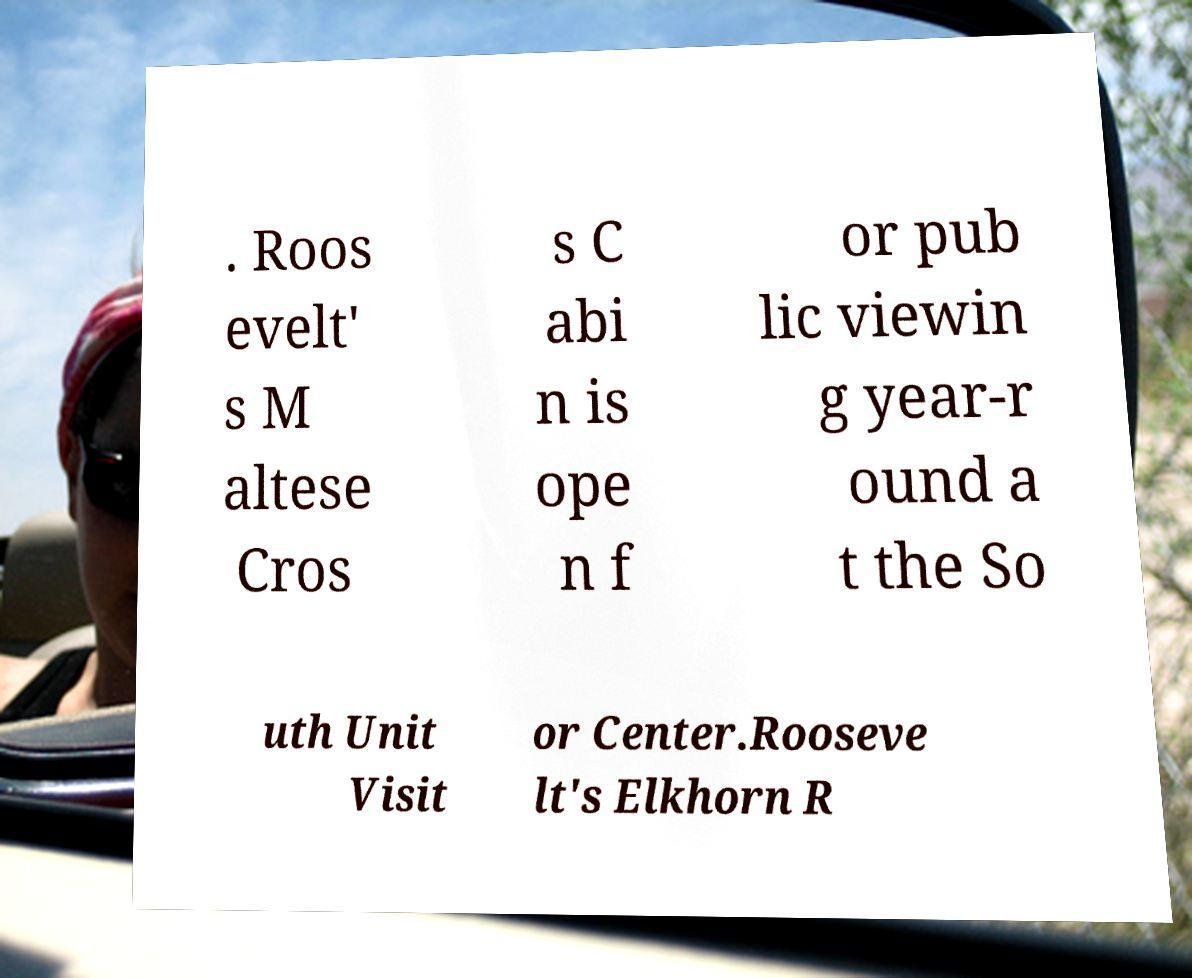Could you assist in decoding the text presented in this image and type it out clearly? . Roos evelt' s M altese Cros s C abi n is ope n f or pub lic viewin g year-r ound a t the So uth Unit Visit or Center.Rooseve lt's Elkhorn R 